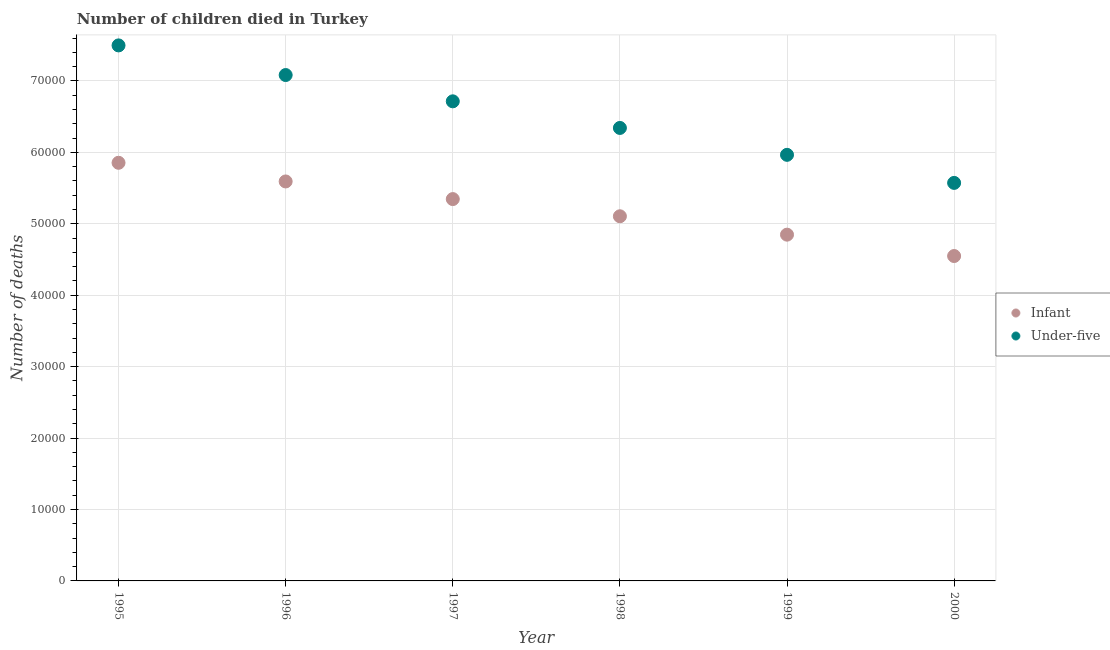How many different coloured dotlines are there?
Make the answer very short. 2. Is the number of dotlines equal to the number of legend labels?
Give a very brief answer. Yes. What is the number of infant deaths in 1998?
Provide a succinct answer. 5.11e+04. Across all years, what is the maximum number of infant deaths?
Offer a terse response. 5.85e+04. Across all years, what is the minimum number of under-five deaths?
Your answer should be compact. 5.57e+04. In which year was the number of under-five deaths maximum?
Give a very brief answer. 1995. In which year was the number of infant deaths minimum?
Your response must be concise. 2000. What is the total number of infant deaths in the graph?
Make the answer very short. 3.13e+05. What is the difference between the number of infant deaths in 1995 and that in 1998?
Provide a short and direct response. 7487. What is the difference between the number of infant deaths in 1996 and the number of under-five deaths in 1998?
Your response must be concise. -7491. What is the average number of infant deaths per year?
Offer a very short reply. 5.22e+04. In the year 1997, what is the difference between the number of infant deaths and number of under-five deaths?
Make the answer very short. -1.37e+04. In how many years, is the number of infant deaths greater than 64000?
Offer a very short reply. 0. What is the ratio of the number of under-five deaths in 1997 to that in 1998?
Your answer should be compact. 1.06. Is the number of under-five deaths in 1998 less than that in 2000?
Your answer should be compact. No. What is the difference between the highest and the second highest number of infant deaths?
Offer a very short reply. 2612. What is the difference between the highest and the lowest number of under-five deaths?
Provide a succinct answer. 1.92e+04. Does the number of infant deaths monotonically increase over the years?
Your response must be concise. No. Is the number of infant deaths strictly greater than the number of under-five deaths over the years?
Ensure brevity in your answer.  No. Does the graph contain any zero values?
Keep it short and to the point. No. Where does the legend appear in the graph?
Your response must be concise. Center right. How are the legend labels stacked?
Give a very brief answer. Vertical. What is the title of the graph?
Provide a short and direct response. Number of children died in Turkey. What is the label or title of the Y-axis?
Offer a very short reply. Number of deaths. What is the Number of deaths in Infant in 1995?
Provide a succinct answer. 5.85e+04. What is the Number of deaths of Under-five in 1995?
Provide a succinct answer. 7.50e+04. What is the Number of deaths in Infant in 1996?
Provide a short and direct response. 5.59e+04. What is the Number of deaths in Under-five in 1996?
Provide a short and direct response. 7.08e+04. What is the Number of deaths in Infant in 1997?
Provide a short and direct response. 5.35e+04. What is the Number of deaths of Under-five in 1997?
Give a very brief answer. 6.71e+04. What is the Number of deaths in Infant in 1998?
Offer a very short reply. 5.11e+04. What is the Number of deaths in Under-five in 1998?
Keep it short and to the point. 6.34e+04. What is the Number of deaths of Infant in 1999?
Provide a short and direct response. 4.85e+04. What is the Number of deaths of Under-five in 1999?
Your answer should be very brief. 5.97e+04. What is the Number of deaths of Infant in 2000?
Provide a short and direct response. 4.55e+04. What is the Number of deaths in Under-five in 2000?
Provide a succinct answer. 5.57e+04. Across all years, what is the maximum Number of deaths in Infant?
Provide a short and direct response. 5.85e+04. Across all years, what is the maximum Number of deaths in Under-five?
Your answer should be compact. 7.50e+04. Across all years, what is the minimum Number of deaths in Infant?
Offer a terse response. 4.55e+04. Across all years, what is the minimum Number of deaths in Under-five?
Keep it short and to the point. 5.57e+04. What is the total Number of deaths of Infant in the graph?
Offer a very short reply. 3.13e+05. What is the total Number of deaths in Under-five in the graph?
Ensure brevity in your answer.  3.92e+05. What is the difference between the Number of deaths in Infant in 1995 and that in 1996?
Offer a terse response. 2612. What is the difference between the Number of deaths of Under-five in 1995 and that in 1996?
Provide a succinct answer. 4149. What is the difference between the Number of deaths in Infant in 1995 and that in 1997?
Provide a short and direct response. 5081. What is the difference between the Number of deaths in Under-five in 1995 and that in 1997?
Your answer should be very brief. 7829. What is the difference between the Number of deaths of Infant in 1995 and that in 1998?
Offer a very short reply. 7487. What is the difference between the Number of deaths in Under-five in 1995 and that in 1998?
Your answer should be very brief. 1.16e+04. What is the difference between the Number of deaths of Infant in 1995 and that in 1999?
Make the answer very short. 1.01e+04. What is the difference between the Number of deaths of Under-five in 1995 and that in 1999?
Your response must be concise. 1.53e+04. What is the difference between the Number of deaths of Infant in 1995 and that in 2000?
Ensure brevity in your answer.  1.31e+04. What is the difference between the Number of deaths of Under-five in 1995 and that in 2000?
Your response must be concise. 1.92e+04. What is the difference between the Number of deaths of Infant in 1996 and that in 1997?
Offer a very short reply. 2469. What is the difference between the Number of deaths of Under-five in 1996 and that in 1997?
Provide a short and direct response. 3680. What is the difference between the Number of deaths in Infant in 1996 and that in 1998?
Ensure brevity in your answer.  4875. What is the difference between the Number of deaths in Under-five in 1996 and that in 1998?
Your answer should be very brief. 7406. What is the difference between the Number of deaths in Infant in 1996 and that in 1999?
Offer a terse response. 7449. What is the difference between the Number of deaths in Under-five in 1996 and that in 1999?
Provide a short and direct response. 1.12e+04. What is the difference between the Number of deaths in Infant in 1996 and that in 2000?
Your answer should be very brief. 1.04e+04. What is the difference between the Number of deaths in Under-five in 1996 and that in 2000?
Your response must be concise. 1.51e+04. What is the difference between the Number of deaths in Infant in 1997 and that in 1998?
Give a very brief answer. 2406. What is the difference between the Number of deaths in Under-five in 1997 and that in 1998?
Keep it short and to the point. 3726. What is the difference between the Number of deaths in Infant in 1997 and that in 1999?
Your answer should be very brief. 4980. What is the difference between the Number of deaths in Under-five in 1997 and that in 1999?
Your answer should be compact. 7491. What is the difference between the Number of deaths of Infant in 1997 and that in 2000?
Offer a very short reply. 7972. What is the difference between the Number of deaths of Under-five in 1997 and that in 2000?
Your answer should be very brief. 1.14e+04. What is the difference between the Number of deaths in Infant in 1998 and that in 1999?
Your response must be concise. 2574. What is the difference between the Number of deaths of Under-five in 1998 and that in 1999?
Offer a very short reply. 3765. What is the difference between the Number of deaths in Infant in 1998 and that in 2000?
Keep it short and to the point. 5566. What is the difference between the Number of deaths in Under-five in 1998 and that in 2000?
Provide a succinct answer. 7694. What is the difference between the Number of deaths of Infant in 1999 and that in 2000?
Your response must be concise. 2992. What is the difference between the Number of deaths in Under-five in 1999 and that in 2000?
Offer a very short reply. 3929. What is the difference between the Number of deaths in Infant in 1995 and the Number of deaths in Under-five in 1996?
Your answer should be very brief. -1.23e+04. What is the difference between the Number of deaths of Infant in 1995 and the Number of deaths of Under-five in 1997?
Provide a short and direct response. -8605. What is the difference between the Number of deaths in Infant in 1995 and the Number of deaths in Under-five in 1998?
Provide a succinct answer. -4879. What is the difference between the Number of deaths in Infant in 1995 and the Number of deaths in Under-five in 1999?
Offer a very short reply. -1114. What is the difference between the Number of deaths in Infant in 1995 and the Number of deaths in Under-five in 2000?
Keep it short and to the point. 2815. What is the difference between the Number of deaths in Infant in 1996 and the Number of deaths in Under-five in 1997?
Provide a succinct answer. -1.12e+04. What is the difference between the Number of deaths in Infant in 1996 and the Number of deaths in Under-five in 1998?
Make the answer very short. -7491. What is the difference between the Number of deaths of Infant in 1996 and the Number of deaths of Under-five in 1999?
Offer a terse response. -3726. What is the difference between the Number of deaths of Infant in 1996 and the Number of deaths of Under-five in 2000?
Give a very brief answer. 203. What is the difference between the Number of deaths of Infant in 1997 and the Number of deaths of Under-five in 1998?
Your answer should be very brief. -9960. What is the difference between the Number of deaths of Infant in 1997 and the Number of deaths of Under-five in 1999?
Your answer should be very brief. -6195. What is the difference between the Number of deaths of Infant in 1997 and the Number of deaths of Under-five in 2000?
Offer a terse response. -2266. What is the difference between the Number of deaths in Infant in 1998 and the Number of deaths in Under-five in 1999?
Make the answer very short. -8601. What is the difference between the Number of deaths of Infant in 1998 and the Number of deaths of Under-five in 2000?
Provide a succinct answer. -4672. What is the difference between the Number of deaths in Infant in 1999 and the Number of deaths in Under-five in 2000?
Ensure brevity in your answer.  -7246. What is the average Number of deaths in Infant per year?
Provide a short and direct response. 5.22e+04. What is the average Number of deaths of Under-five per year?
Make the answer very short. 6.53e+04. In the year 1995, what is the difference between the Number of deaths of Infant and Number of deaths of Under-five?
Offer a very short reply. -1.64e+04. In the year 1996, what is the difference between the Number of deaths in Infant and Number of deaths in Under-five?
Your answer should be compact. -1.49e+04. In the year 1997, what is the difference between the Number of deaths in Infant and Number of deaths in Under-five?
Provide a short and direct response. -1.37e+04. In the year 1998, what is the difference between the Number of deaths of Infant and Number of deaths of Under-five?
Keep it short and to the point. -1.24e+04. In the year 1999, what is the difference between the Number of deaths of Infant and Number of deaths of Under-five?
Ensure brevity in your answer.  -1.12e+04. In the year 2000, what is the difference between the Number of deaths of Infant and Number of deaths of Under-five?
Provide a short and direct response. -1.02e+04. What is the ratio of the Number of deaths in Infant in 1995 to that in 1996?
Provide a succinct answer. 1.05. What is the ratio of the Number of deaths of Under-five in 1995 to that in 1996?
Ensure brevity in your answer.  1.06. What is the ratio of the Number of deaths in Infant in 1995 to that in 1997?
Give a very brief answer. 1.09. What is the ratio of the Number of deaths in Under-five in 1995 to that in 1997?
Your answer should be very brief. 1.12. What is the ratio of the Number of deaths of Infant in 1995 to that in 1998?
Give a very brief answer. 1.15. What is the ratio of the Number of deaths in Under-five in 1995 to that in 1998?
Make the answer very short. 1.18. What is the ratio of the Number of deaths in Infant in 1995 to that in 1999?
Provide a succinct answer. 1.21. What is the ratio of the Number of deaths in Under-five in 1995 to that in 1999?
Give a very brief answer. 1.26. What is the ratio of the Number of deaths of Infant in 1995 to that in 2000?
Your answer should be very brief. 1.29. What is the ratio of the Number of deaths of Under-five in 1995 to that in 2000?
Provide a short and direct response. 1.35. What is the ratio of the Number of deaths of Infant in 1996 to that in 1997?
Ensure brevity in your answer.  1.05. What is the ratio of the Number of deaths of Under-five in 1996 to that in 1997?
Provide a succinct answer. 1.05. What is the ratio of the Number of deaths of Infant in 1996 to that in 1998?
Your answer should be very brief. 1.1. What is the ratio of the Number of deaths in Under-five in 1996 to that in 1998?
Provide a short and direct response. 1.12. What is the ratio of the Number of deaths of Infant in 1996 to that in 1999?
Offer a very short reply. 1.15. What is the ratio of the Number of deaths in Under-five in 1996 to that in 1999?
Offer a very short reply. 1.19. What is the ratio of the Number of deaths in Infant in 1996 to that in 2000?
Offer a terse response. 1.23. What is the ratio of the Number of deaths in Under-five in 1996 to that in 2000?
Provide a short and direct response. 1.27. What is the ratio of the Number of deaths of Infant in 1997 to that in 1998?
Offer a very short reply. 1.05. What is the ratio of the Number of deaths in Under-five in 1997 to that in 1998?
Offer a very short reply. 1.06. What is the ratio of the Number of deaths in Infant in 1997 to that in 1999?
Offer a terse response. 1.1. What is the ratio of the Number of deaths of Under-five in 1997 to that in 1999?
Provide a succinct answer. 1.13. What is the ratio of the Number of deaths in Infant in 1997 to that in 2000?
Give a very brief answer. 1.18. What is the ratio of the Number of deaths of Under-five in 1997 to that in 2000?
Your response must be concise. 1.2. What is the ratio of the Number of deaths in Infant in 1998 to that in 1999?
Give a very brief answer. 1.05. What is the ratio of the Number of deaths in Under-five in 1998 to that in 1999?
Offer a terse response. 1.06. What is the ratio of the Number of deaths in Infant in 1998 to that in 2000?
Keep it short and to the point. 1.12. What is the ratio of the Number of deaths of Under-five in 1998 to that in 2000?
Your answer should be compact. 1.14. What is the ratio of the Number of deaths of Infant in 1999 to that in 2000?
Give a very brief answer. 1.07. What is the ratio of the Number of deaths of Under-five in 1999 to that in 2000?
Provide a succinct answer. 1.07. What is the difference between the highest and the second highest Number of deaths in Infant?
Keep it short and to the point. 2612. What is the difference between the highest and the second highest Number of deaths in Under-five?
Your answer should be very brief. 4149. What is the difference between the highest and the lowest Number of deaths in Infant?
Offer a terse response. 1.31e+04. What is the difference between the highest and the lowest Number of deaths of Under-five?
Your response must be concise. 1.92e+04. 